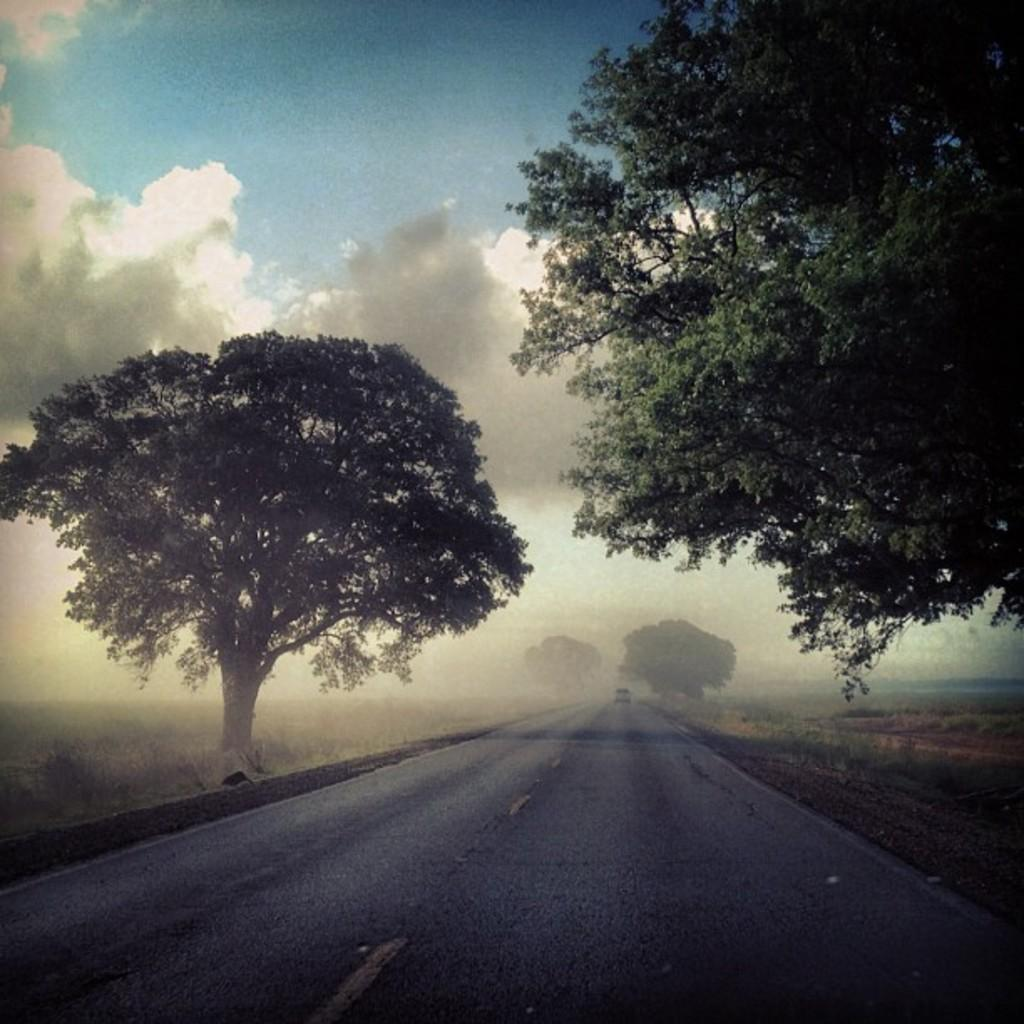What is the main feature in the middle of the image? There is a road in the middle of the image. What can be seen on both sides of the road? There are trees and grass on both sides of the road. What is visible in the background of the image? The sky is visible in the background of the image, with clouds present. Can you see the face of the person walking on the grass in the image? There is no person walking on the grass in the image, and therefore no face can be seen. 